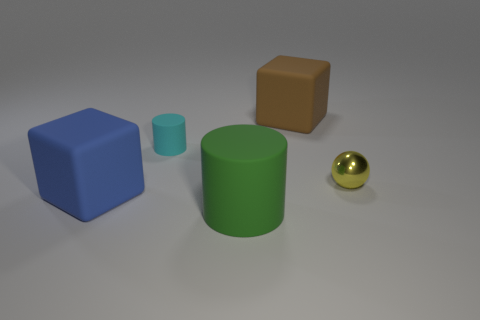What material is the tiny yellow sphere?
Keep it short and to the point. Metal. What material is the thing that is in front of the large rubber block to the left of the large cube behind the small ball?
Give a very brief answer. Rubber. There is a cylinder behind the small ball; does it have the same size as the rubber cylinder in front of the tiny yellow metal ball?
Make the answer very short. No. What number of other objects are the same material as the large green object?
Provide a succinct answer. 3. How many rubber objects are either big cylinders or large red objects?
Ensure brevity in your answer.  1. Are there fewer big green shiny balls than large green cylinders?
Make the answer very short. Yes. Does the metal sphere have the same size as the matte cylinder on the left side of the green cylinder?
Provide a succinct answer. Yes. Is there anything else that has the same shape as the tiny yellow thing?
Your answer should be very brief. No. The cyan matte cylinder is what size?
Provide a short and direct response. Small. Is the number of green cylinders that are to the left of the big blue rubber thing less than the number of matte blocks?
Offer a very short reply. Yes. 